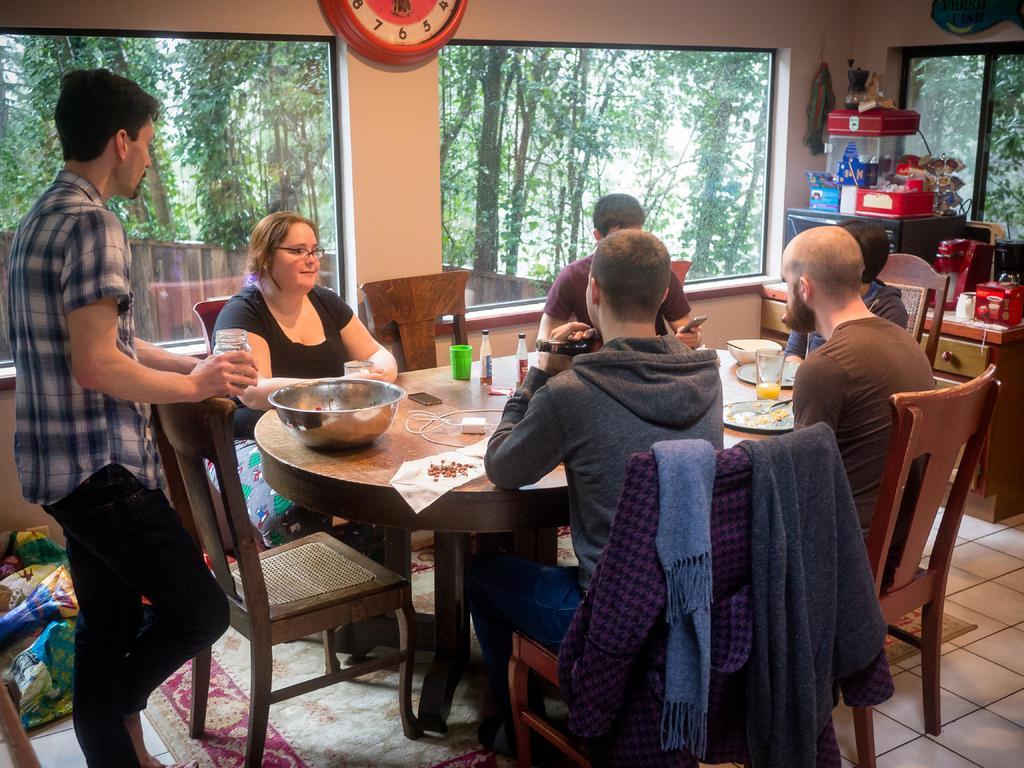Describe this image in one or two sentences. In this picture we can see some persons were some women in middle is smiling and in front of them there is table and on table we can see vessel, charger, tissue paper, bottle, glass, plate, bowl, mobile and in the background we can see watch, tree, window, cupboards, lamp. 